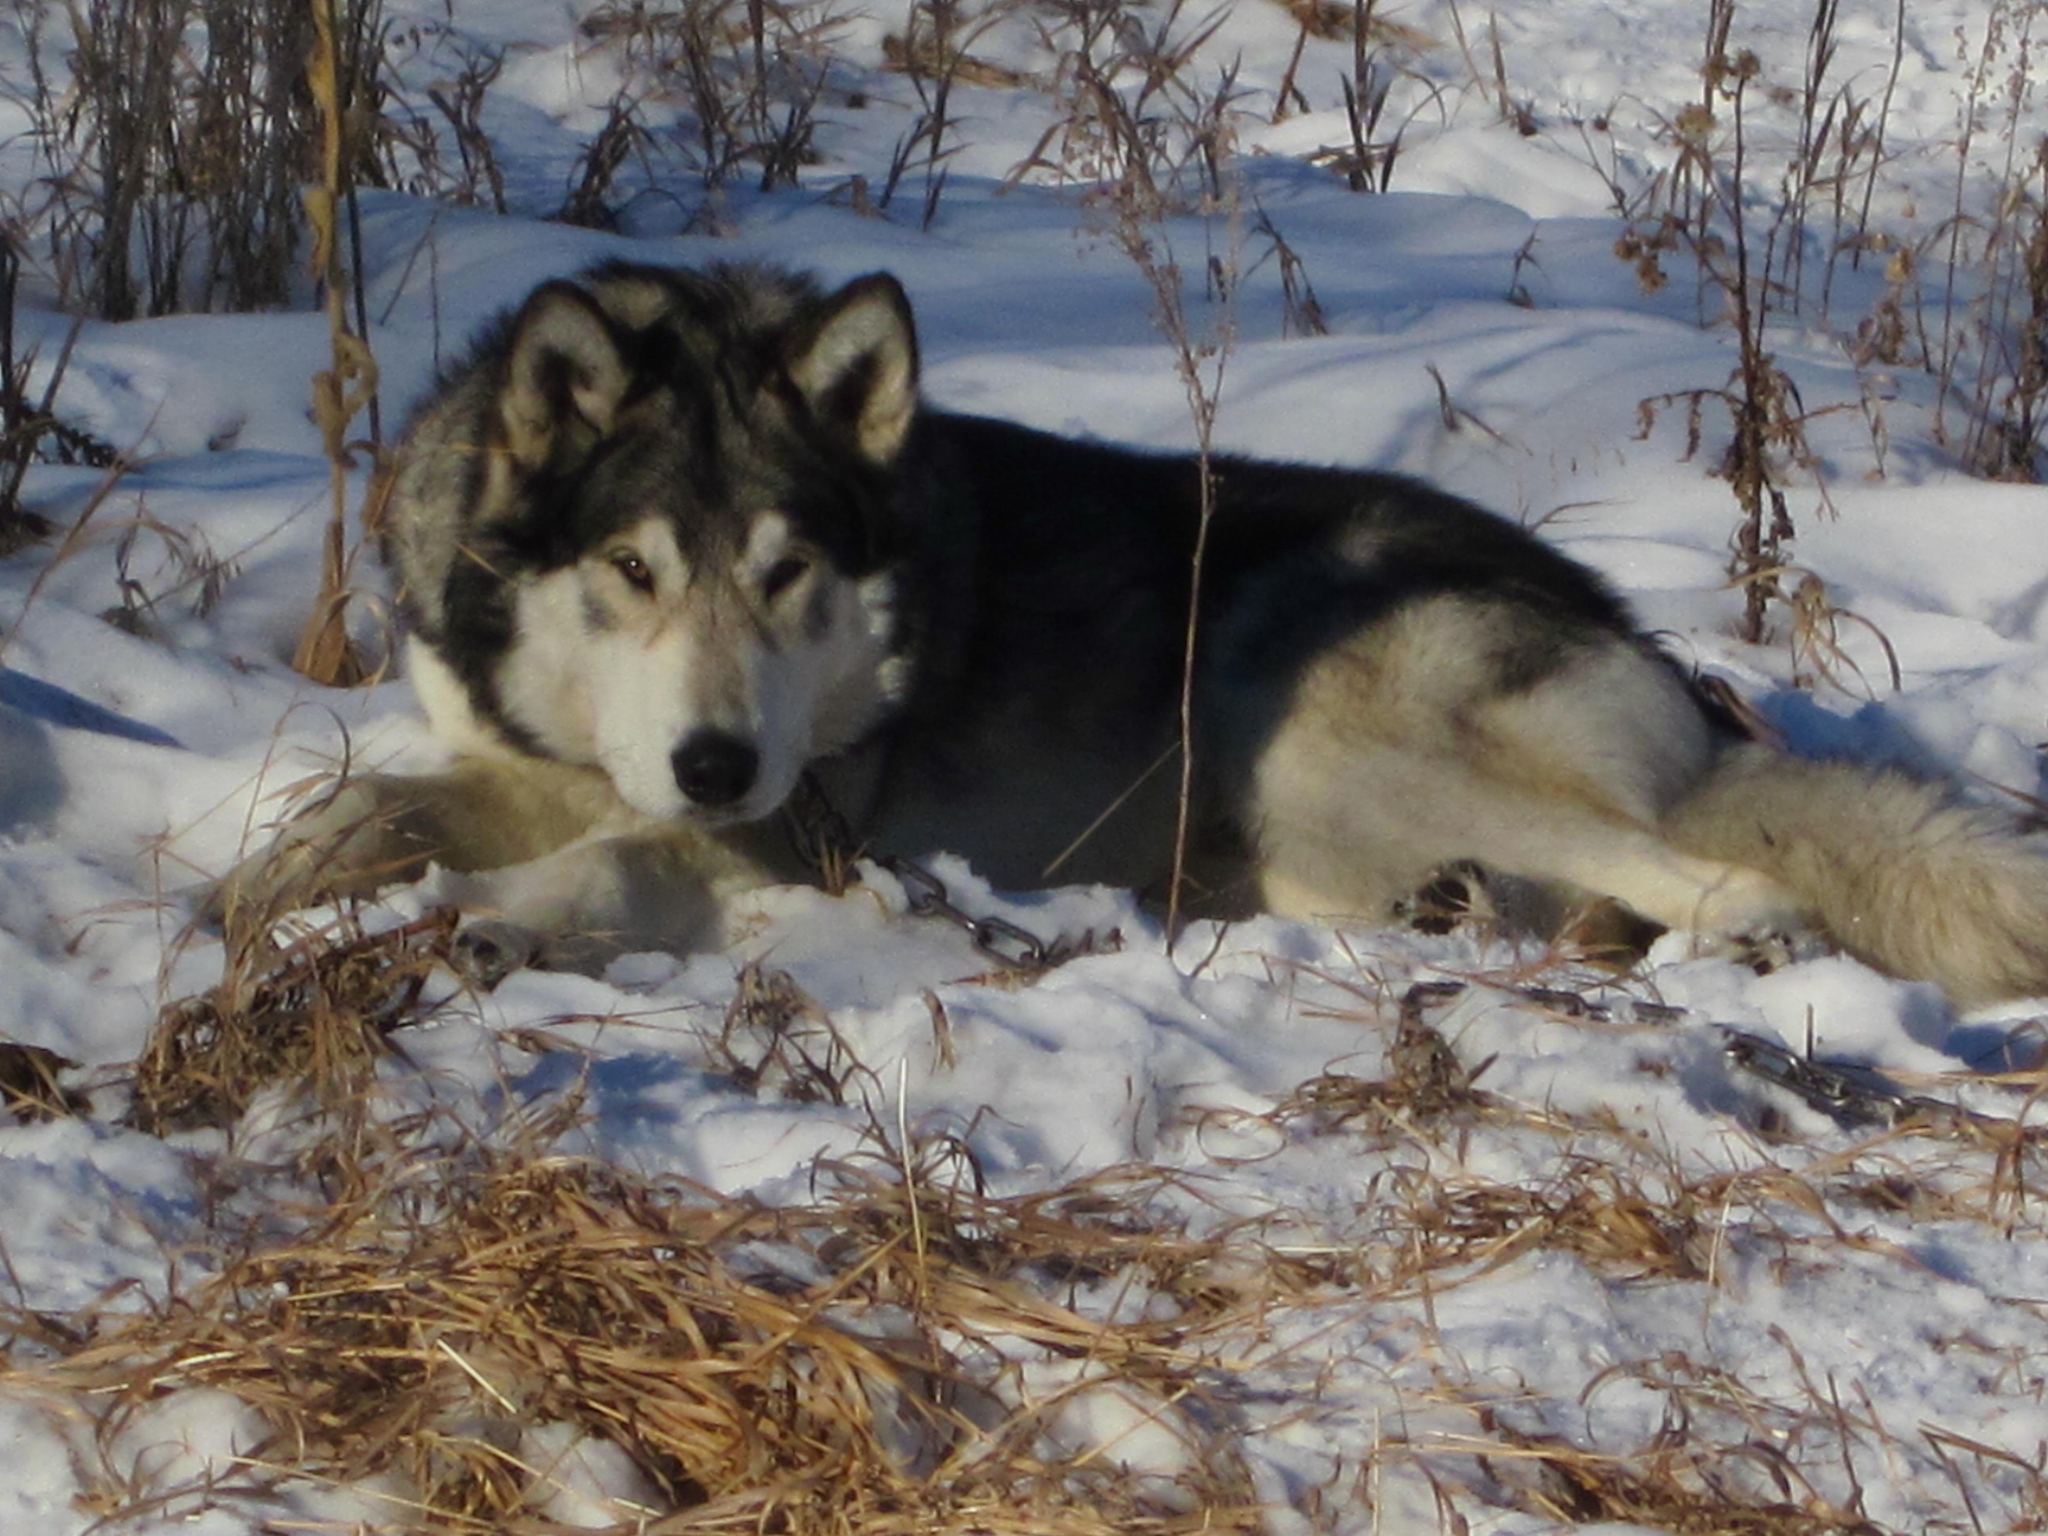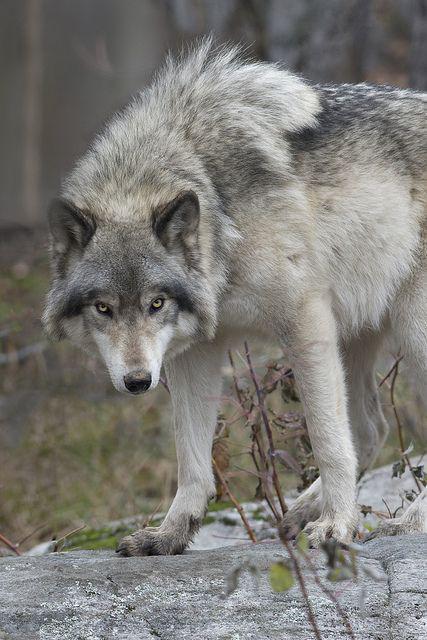The first image is the image on the left, the second image is the image on the right. Assess this claim about the two images: "There are a total of four wolves.". Correct or not? Answer yes or no. No. The first image is the image on the left, the second image is the image on the right. Evaluate the accuracy of this statement regarding the images: "There are at most two wolves total". Is it true? Answer yes or no. Yes. 